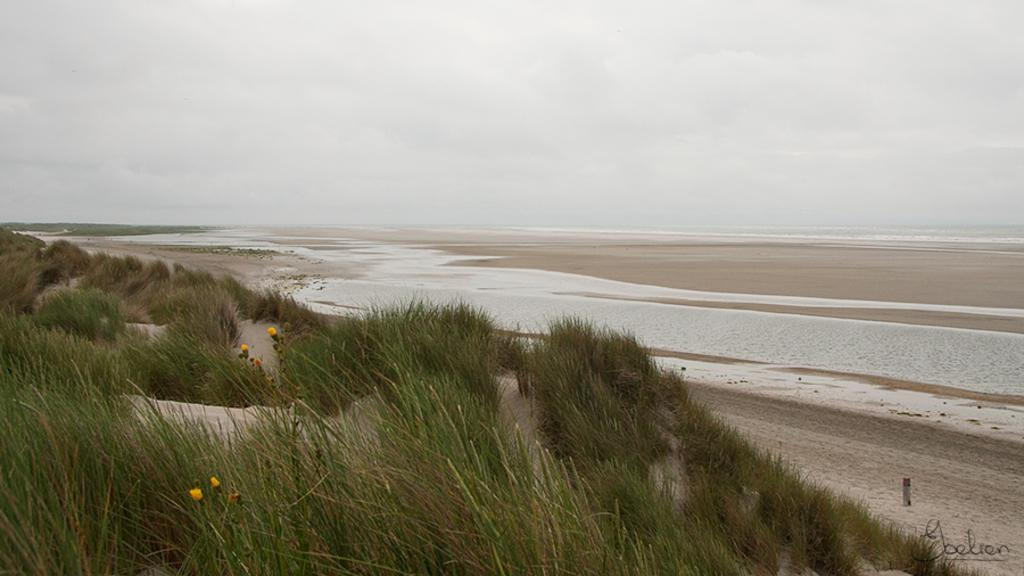What type of vegetation can be seen in the image? There is grass and flowers visible in the image. What else can be seen in the image besides vegetation? There is water visible in the image. How would you describe the sky in the image? The sky is cloudy in the image. Is there any text or marking in the image? Yes, there is a watermark at the bottom right side of the image. What type of vegetable is growing in the image? There is no vegetable growing in the image; it features grass and flowers. How does the wind affect the clouds in the image? The image does not show any wind or its effects on the clouds; it only shows a cloudy sky. 